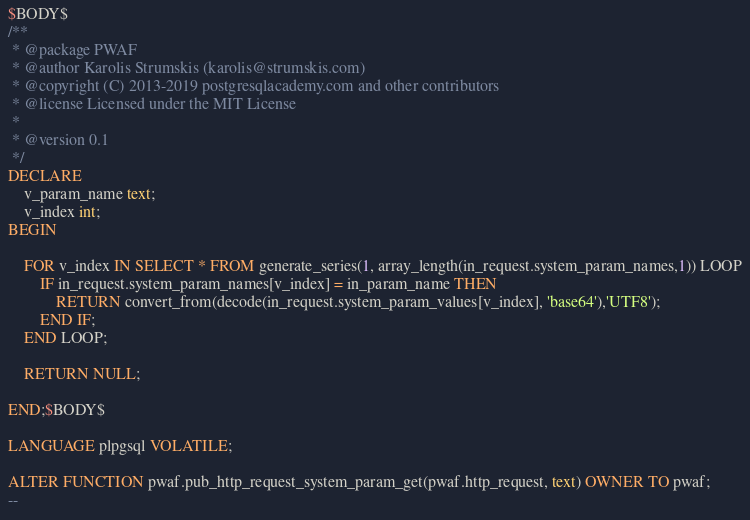<code> <loc_0><loc_0><loc_500><loc_500><_SQL_>$BODY$
/**
 * @package PWAF
 * @author Karolis Strumskis (karolis@strumskis.com)
 * @copyright (C) 2013-2019 postgresqlacademy.com and other contributors
 * @license Licensed under the MIT License
 * 
 * @version 0.1
 */
DECLARE
	v_param_name text;
	v_index int;
BEGIN

	FOR v_index IN SELECT * FROM generate_series(1, array_length(in_request.system_param_names,1)) LOOP
		IF in_request.system_param_names[v_index] = in_param_name THEN
			RETURN convert_from(decode(in_request.system_param_values[v_index], 'base64'),'UTF8');
		END IF;
	END LOOP;

	RETURN NULL;

END;$BODY$

LANGUAGE plpgsql VOLATILE;

ALTER FUNCTION pwaf.pub_http_request_system_param_get(pwaf.http_request, text) OWNER TO pwaf;
--</code> 